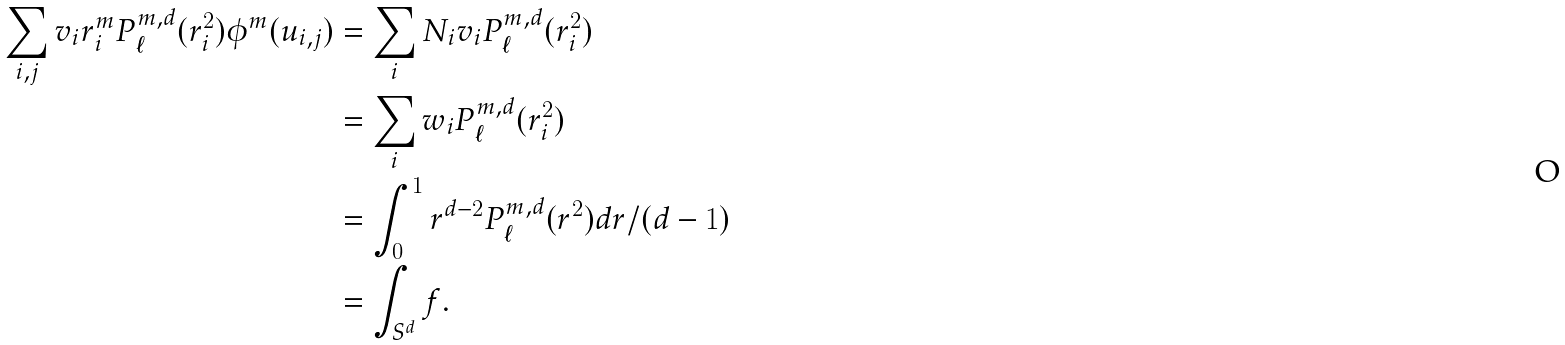Convert formula to latex. <formula><loc_0><loc_0><loc_500><loc_500>\sum _ { i , j } v _ { i } r _ { i } ^ { m } P ^ { m , d } _ { \ell } ( r _ { i } ^ { 2 } ) \phi ^ { m } ( u _ { i , j } ) & = \sum _ { i } N _ { i } v _ { i } P ^ { m , d } _ { \ell } ( r _ { i } ^ { 2 } ) \\ & = \sum _ { i } w _ { i } P ^ { m , d } _ { \ell } ( r _ { i } ^ { 2 } ) \\ & = \int _ { 0 } ^ { 1 } r ^ { d - 2 } P ^ { m , d } _ { \ell } ( r ^ { 2 } ) d r / ( d - 1 ) \\ & = \int _ { S ^ { d } } f .</formula> 